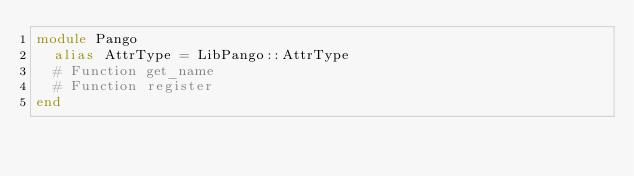Convert code to text. <code><loc_0><loc_0><loc_500><loc_500><_Crystal_>module Pango
  alias AttrType = LibPango::AttrType
  # Function get_name
  # Function register
end

</code> 